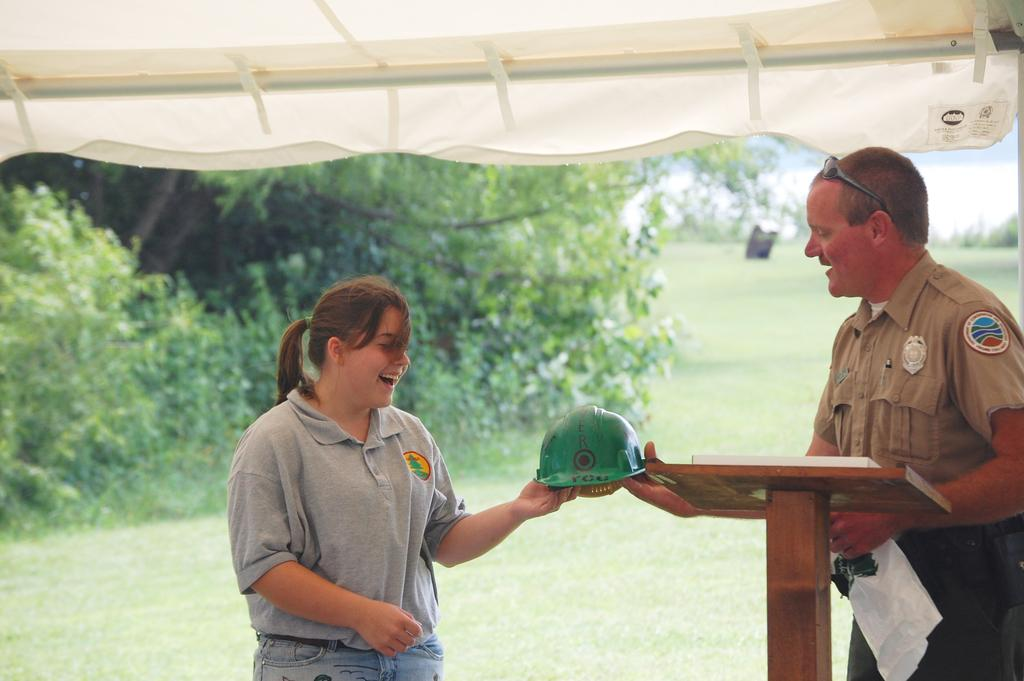How many people are present in the image? There is a man and a woman present in the image. What are the man and woman holding in their hands? The man or woman is holding a helmet in their hands. What can be seen in the background of the image? There are trees, sky, ground, and a lectern visible in the background of the image. What type of question is being asked by the man in the image? There is no indication in the image that a question is being asked, and the man's actions or expressions do not suggest any specific question. 